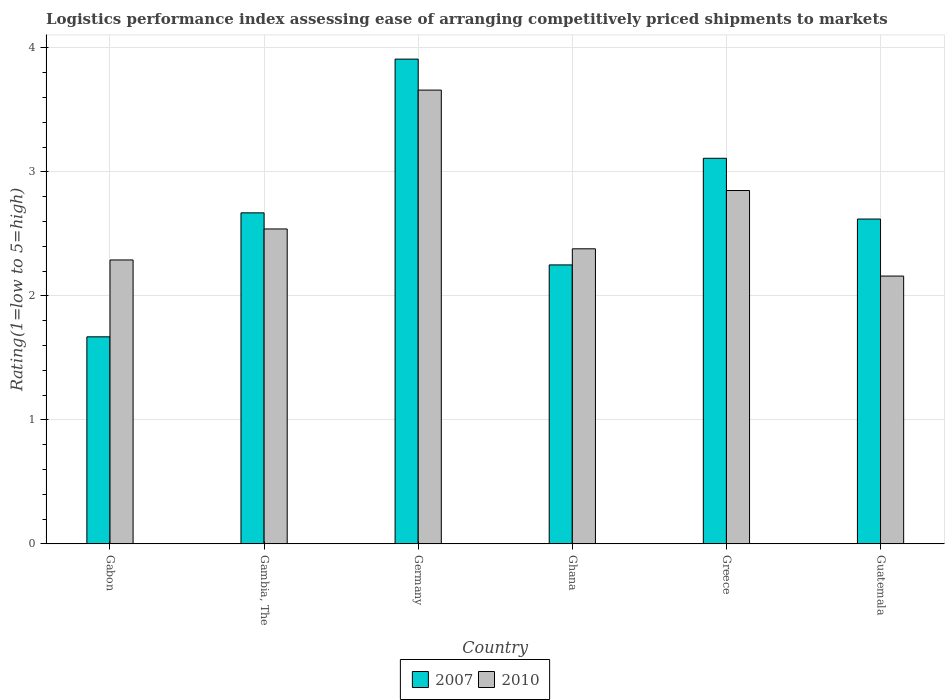How many different coloured bars are there?
Keep it short and to the point. 2. Are the number of bars on each tick of the X-axis equal?
Offer a very short reply. Yes. How many bars are there on the 6th tick from the right?
Your response must be concise. 2. What is the Logistic performance index in 2010 in Germany?
Offer a very short reply. 3.66. Across all countries, what is the maximum Logistic performance index in 2010?
Ensure brevity in your answer.  3.66. Across all countries, what is the minimum Logistic performance index in 2010?
Give a very brief answer. 2.16. In which country was the Logistic performance index in 2010 minimum?
Offer a very short reply. Guatemala. What is the total Logistic performance index in 2010 in the graph?
Your response must be concise. 15.88. What is the difference between the Logistic performance index in 2010 in Gabon and that in Gambia, The?
Provide a succinct answer. -0.25. What is the difference between the Logistic performance index in 2007 in Ghana and the Logistic performance index in 2010 in Guatemala?
Provide a succinct answer. 0.09. What is the average Logistic performance index in 2010 per country?
Offer a terse response. 2.65. What is the difference between the Logistic performance index of/in 2007 and Logistic performance index of/in 2010 in Greece?
Provide a succinct answer. 0.26. What is the ratio of the Logistic performance index in 2010 in Gambia, The to that in Guatemala?
Your answer should be very brief. 1.18. Is the Logistic performance index in 2010 in Ghana less than that in Greece?
Your response must be concise. Yes. What is the difference between the highest and the second highest Logistic performance index in 2007?
Make the answer very short. 0.44. What is the difference between the highest and the lowest Logistic performance index in 2007?
Your response must be concise. 2.24. In how many countries, is the Logistic performance index in 2010 greater than the average Logistic performance index in 2010 taken over all countries?
Your response must be concise. 2. Is the sum of the Logistic performance index in 2007 in Ghana and Guatemala greater than the maximum Logistic performance index in 2010 across all countries?
Offer a very short reply. Yes. What does the 1st bar from the right in Gabon represents?
Your response must be concise. 2010. How many bars are there?
Give a very brief answer. 12. Are all the bars in the graph horizontal?
Your response must be concise. No. How many countries are there in the graph?
Offer a terse response. 6. What is the difference between two consecutive major ticks on the Y-axis?
Offer a very short reply. 1. Where does the legend appear in the graph?
Offer a terse response. Bottom center. How many legend labels are there?
Your response must be concise. 2. What is the title of the graph?
Provide a succinct answer. Logistics performance index assessing ease of arranging competitively priced shipments to markets. What is the label or title of the Y-axis?
Give a very brief answer. Rating(1=low to 5=high). What is the Rating(1=low to 5=high) of 2007 in Gabon?
Your response must be concise. 1.67. What is the Rating(1=low to 5=high) in 2010 in Gabon?
Your answer should be very brief. 2.29. What is the Rating(1=low to 5=high) of 2007 in Gambia, The?
Provide a short and direct response. 2.67. What is the Rating(1=low to 5=high) in 2010 in Gambia, The?
Give a very brief answer. 2.54. What is the Rating(1=low to 5=high) of 2007 in Germany?
Ensure brevity in your answer.  3.91. What is the Rating(1=low to 5=high) in 2010 in Germany?
Give a very brief answer. 3.66. What is the Rating(1=low to 5=high) in 2007 in Ghana?
Offer a terse response. 2.25. What is the Rating(1=low to 5=high) of 2010 in Ghana?
Your answer should be very brief. 2.38. What is the Rating(1=low to 5=high) in 2007 in Greece?
Give a very brief answer. 3.11. What is the Rating(1=low to 5=high) of 2010 in Greece?
Provide a short and direct response. 2.85. What is the Rating(1=low to 5=high) of 2007 in Guatemala?
Your response must be concise. 2.62. What is the Rating(1=low to 5=high) in 2010 in Guatemala?
Ensure brevity in your answer.  2.16. Across all countries, what is the maximum Rating(1=low to 5=high) in 2007?
Keep it short and to the point. 3.91. Across all countries, what is the maximum Rating(1=low to 5=high) in 2010?
Offer a terse response. 3.66. Across all countries, what is the minimum Rating(1=low to 5=high) of 2007?
Your response must be concise. 1.67. Across all countries, what is the minimum Rating(1=low to 5=high) in 2010?
Make the answer very short. 2.16. What is the total Rating(1=low to 5=high) in 2007 in the graph?
Give a very brief answer. 16.23. What is the total Rating(1=low to 5=high) in 2010 in the graph?
Provide a short and direct response. 15.88. What is the difference between the Rating(1=low to 5=high) of 2010 in Gabon and that in Gambia, The?
Offer a very short reply. -0.25. What is the difference between the Rating(1=low to 5=high) in 2007 in Gabon and that in Germany?
Your answer should be very brief. -2.24. What is the difference between the Rating(1=low to 5=high) in 2010 in Gabon and that in Germany?
Provide a succinct answer. -1.37. What is the difference between the Rating(1=low to 5=high) in 2007 in Gabon and that in Ghana?
Make the answer very short. -0.58. What is the difference between the Rating(1=low to 5=high) in 2010 in Gabon and that in Ghana?
Your answer should be compact. -0.09. What is the difference between the Rating(1=low to 5=high) of 2007 in Gabon and that in Greece?
Keep it short and to the point. -1.44. What is the difference between the Rating(1=low to 5=high) in 2010 in Gabon and that in Greece?
Your answer should be compact. -0.56. What is the difference between the Rating(1=low to 5=high) in 2007 in Gabon and that in Guatemala?
Your answer should be very brief. -0.95. What is the difference between the Rating(1=low to 5=high) in 2010 in Gabon and that in Guatemala?
Your answer should be very brief. 0.13. What is the difference between the Rating(1=low to 5=high) of 2007 in Gambia, The and that in Germany?
Provide a succinct answer. -1.24. What is the difference between the Rating(1=low to 5=high) in 2010 in Gambia, The and that in Germany?
Your response must be concise. -1.12. What is the difference between the Rating(1=low to 5=high) in 2007 in Gambia, The and that in Ghana?
Your answer should be very brief. 0.42. What is the difference between the Rating(1=low to 5=high) in 2010 in Gambia, The and that in Ghana?
Your response must be concise. 0.16. What is the difference between the Rating(1=low to 5=high) in 2007 in Gambia, The and that in Greece?
Provide a short and direct response. -0.44. What is the difference between the Rating(1=low to 5=high) of 2010 in Gambia, The and that in Greece?
Your response must be concise. -0.31. What is the difference between the Rating(1=low to 5=high) of 2007 in Gambia, The and that in Guatemala?
Provide a succinct answer. 0.05. What is the difference between the Rating(1=low to 5=high) of 2010 in Gambia, The and that in Guatemala?
Offer a terse response. 0.38. What is the difference between the Rating(1=low to 5=high) in 2007 in Germany and that in Ghana?
Provide a short and direct response. 1.66. What is the difference between the Rating(1=low to 5=high) of 2010 in Germany and that in Ghana?
Your response must be concise. 1.28. What is the difference between the Rating(1=low to 5=high) in 2007 in Germany and that in Greece?
Give a very brief answer. 0.8. What is the difference between the Rating(1=low to 5=high) of 2010 in Germany and that in Greece?
Give a very brief answer. 0.81. What is the difference between the Rating(1=low to 5=high) of 2007 in Germany and that in Guatemala?
Offer a terse response. 1.29. What is the difference between the Rating(1=low to 5=high) in 2007 in Ghana and that in Greece?
Give a very brief answer. -0.86. What is the difference between the Rating(1=low to 5=high) in 2010 in Ghana and that in Greece?
Provide a succinct answer. -0.47. What is the difference between the Rating(1=low to 5=high) of 2007 in Ghana and that in Guatemala?
Keep it short and to the point. -0.37. What is the difference between the Rating(1=low to 5=high) of 2010 in Ghana and that in Guatemala?
Your response must be concise. 0.22. What is the difference between the Rating(1=low to 5=high) in 2007 in Greece and that in Guatemala?
Make the answer very short. 0.49. What is the difference between the Rating(1=low to 5=high) of 2010 in Greece and that in Guatemala?
Your response must be concise. 0.69. What is the difference between the Rating(1=low to 5=high) in 2007 in Gabon and the Rating(1=low to 5=high) in 2010 in Gambia, The?
Your response must be concise. -0.87. What is the difference between the Rating(1=low to 5=high) in 2007 in Gabon and the Rating(1=low to 5=high) in 2010 in Germany?
Offer a very short reply. -1.99. What is the difference between the Rating(1=low to 5=high) in 2007 in Gabon and the Rating(1=low to 5=high) in 2010 in Ghana?
Offer a terse response. -0.71. What is the difference between the Rating(1=low to 5=high) in 2007 in Gabon and the Rating(1=low to 5=high) in 2010 in Greece?
Provide a succinct answer. -1.18. What is the difference between the Rating(1=low to 5=high) in 2007 in Gabon and the Rating(1=low to 5=high) in 2010 in Guatemala?
Provide a short and direct response. -0.49. What is the difference between the Rating(1=low to 5=high) of 2007 in Gambia, The and the Rating(1=low to 5=high) of 2010 in Germany?
Your answer should be compact. -0.99. What is the difference between the Rating(1=low to 5=high) of 2007 in Gambia, The and the Rating(1=low to 5=high) of 2010 in Ghana?
Make the answer very short. 0.29. What is the difference between the Rating(1=low to 5=high) in 2007 in Gambia, The and the Rating(1=low to 5=high) in 2010 in Greece?
Provide a short and direct response. -0.18. What is the difference between the Rating(1=low to 5=high) in 2007 in Gambia, The and the Rating(1=low to 5=high) in 2010 in Guatemala?
Your answer should be very brief. 0.51. What is the difference between the Rating(1=low to 5=high) of 2007 in Germany and the Rating(1=low to 5=high) of 2010 in Ghana?
Offer a terse response. 1.53. What is the difference between the Rating(1=low to 5=high) of 2007 in Germany and the Rating(1=low to 5=high) of 2010 in Greece?
Your answer should be compact. 1.06. What is the difference between the Rating(1=low to 5=high) of 2007 in Ghana and the Rating(1=low to 5=high) of 2010 in Greece?
Provide a succinct answer. -0.6. What is the difference between the Rating(1=low to 5=high) in 2007 in Ghana and the Rating(1=low to 5=high) in 2010 in Guatemala?
Make the answer very short. 0.09. What is the average Rating(1=low to 5=high) in 2007 per country?
Ensure brevity in your answer.  2.71. What is the average Rating(1=low to 5=high) in 2010 per country?
Provide a succinct answer. 2.65. What is the difference between the Rating(1=low to 5=high) of 2007 and Rating(1=low to 5=high) of 2010 in Gabon?
Offer a terse response. -0.62. What is the difference between the Rating(1=low to 5=high) in 2007 and Rating(1=low to 5=high) in 2010 in Gambia, The?
Give a very brief answer. 0.13. What is the difference between the Rating(1=low to 5=high) of 2007 and Rating(1=low to 5=high) of 2010 in Germany?
Your response must be concise. 0.25. What is the difference between the Rating(1=low to 5=high) in 2007 and Rating(1=low to 5=high) in 2010 in Ghana?
Your answer should be very brief. -0.13. What is the difference between the Rating(1=low to 5=high) of 2007 and Rating(1=low to 5=high) of 2010 in Greece?
Give a very brief answer. 0.26. What is the difference between the Rating(1=low to 5=high) of 2007 and Rating(1=low to 5=high) of 2010 in Guatemala?
Offer a terse response. 0.46. What is the ratio of the Rating(1=low to 5=high) of 2007 in Gabon to that in Gambia, The?
Provide a short and direct response. 0.63. What is the ratio of the Rating(1=low to 5=high) in 2010 in Gabon to that in Gambia, The?
Keep it short and to the point. 0.9. What is the ratio of the Rating(1=low to 5=high) in 2007 in Gabon to that in Germany?
Ensure brevity in your answer.  0.43. What is the ratio of the Rating(1=low to 5=high) in 2010 in Gabon to that in Germany?
Keep it short and to the point. 0.63. What is the ratio of the Rating(1=low to 5=high) of 2007 in Gabon to that in Ghana?
Your answer should be compact. 0.74. What is the ratio of the Rating(1=low to 5=high) of 2010 in Gabon to that in Ghana?
Your answer should be very brief. 0.96. What is the ratio of the Rating(1=low to 5=high) in 2007 in Gabon to that in Greece?
Provide a succinct answer. 0.54. What is the ratio of the Rating(1=low to 5=high) of 2010 in Gabon to that in Greece?
Give a very brief answer. 0.8. What is the ratio of the Rating(1=low to 5=high) of 2007 in Gabon to that in Guatemala?
Your response must be concise. 0.64. What is the ratio of the Rating(1=low to 5=high) of 2010 in Gabon to that in Guatemala?
Your answer should be very brief. 1.06. What is the ratio of the Rating(1=low to 5=high) of 2007 in Gambia, The to that in Germany?
Make the answer very short. 0.68. What is the ratio of the Rating(1=low to 5=high) of 2010 in Gambia, The to that in Germany?
Ensure brevity in your answer.  0.69. What is the ratio of the Rating(1=low to 5=high) in 2007 in Gambia, The to that in Ghana?
Ensure brevity in your answer.  1.19. What is the ratio of the Rating(1=low to 5=high) in 2010 in Gambia, The to that in Ghana?
Offer a very short reply. 1.07. What is the ratio of the Rating(1=low to 5=high) in 2007 in Gambia, The to that in Greece?
Keep it short and to the point. 0.86. What is the ratio of the Rating(1=low to 5=high) of 2010 in Gambia, The to that in Greece?
Your answer should be compact. 0.89. What is the ratio of the Rating(1=low to 5=high) in 2007 in Gambia, The to that in Guatemala?
Ensure brevity in your answer.  1.02. What is the ratio of the Rating(1=low to 5=high) in 2010 in Gambia, The to that in Guatemala?
Your response must be concise. 1.18. What is the ratio of the Rating(1=low to 5=high) of 2007 in Germany to that in Ghana?
Provide a short and direct response. 1.74. What is the ratio of the Rating(1=low to 5=high) of 2010 in Germany to that in Ghana?
Your answer should be compact. 1.54. What is the ratio of the Rating(1=low to 5=high) in 2007 in Germany to that in Greece?
Provide a succinct answer. 1.26. What is the ratio of the Rating(1=low to 5=high) of 2010 in Germany to that in Greece?
Your response must be concise. 1.28. What is the ratio of the Rating(1=low to 5=high) of 2007 in Germany to that in Guatemala?
Keep it short and to the point. 1.49. What is the ratio of the Rating(1=low to 5=high) in 2010 in Germany to that in Guatemala?
Ensure brevity in your answer.  1.69. What is the ratio of the Rating(1=low to 5=high) in 2007 in Ghana to that in Greece?
Give a very brief answer. 0.72. What is the ratio of the Rating(1=low to 5=high) in 2010 in Ghana to that in Greece?
Offer a terse response. 0.84. What is the ratio of the Rating(1=low to 5=high) of 2007 in Ghana to that in Guatemala?
Your response must be concise. 0.86. What is the ratio of the Rating(1=low to 5=high) in 2010 in Ghana to that in Guatemala?
Your response must be concise. 1.1. What is the ratio of the Rating(1=low to 5=high) in 2007 in Greece to that in Guatemala?
Your response must be concise. 1.19. What is the ratio of the Rating(1=low to 5=high) in 2010 in Greece to that in Guatemala?
Your answer should be compact. 1.32. What is the difference between the highest and the second highest Rating(1=low to 5=high) in 2007?
Keep it short and to the point. 0.8. What is the difference between the highest and the second highest Rating(1=low to 5=high) of 2010?
Give a very brief answer. 0.81. What is the difference between the highest and the lowest Rating(1=low to 5=high) in 2007?
Your response must be concise. 2.24. 